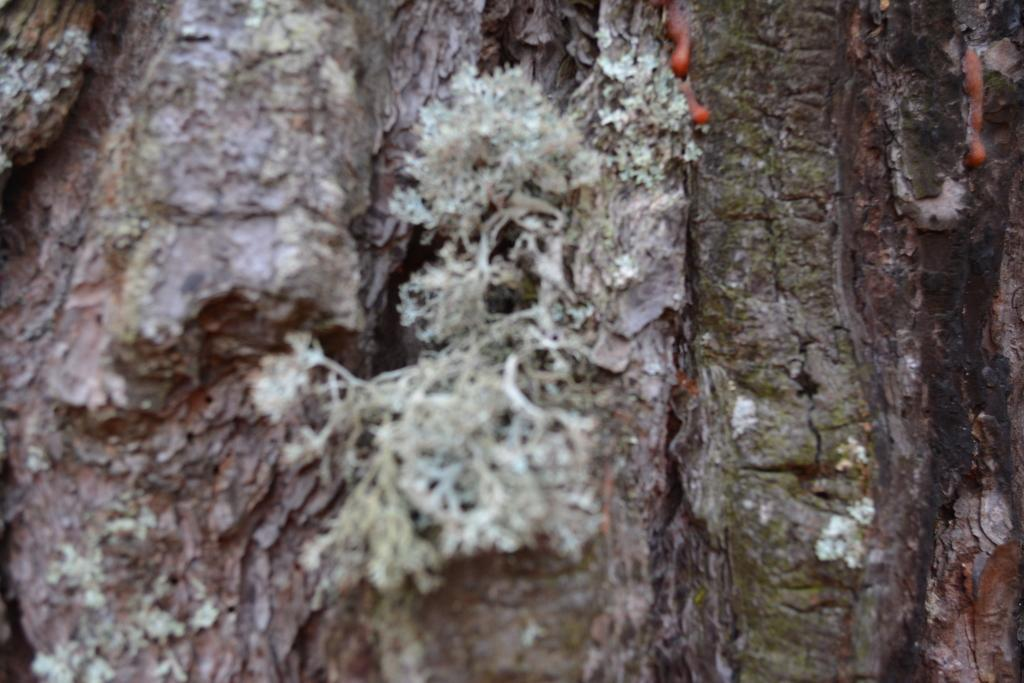What is the main object in the image? There is a trunk in the image. What is growing on the trunk? There are plants on the trunk. What type of map can be seen on the trunk? There is no map present on the trunk; it only has plants growing on it. 